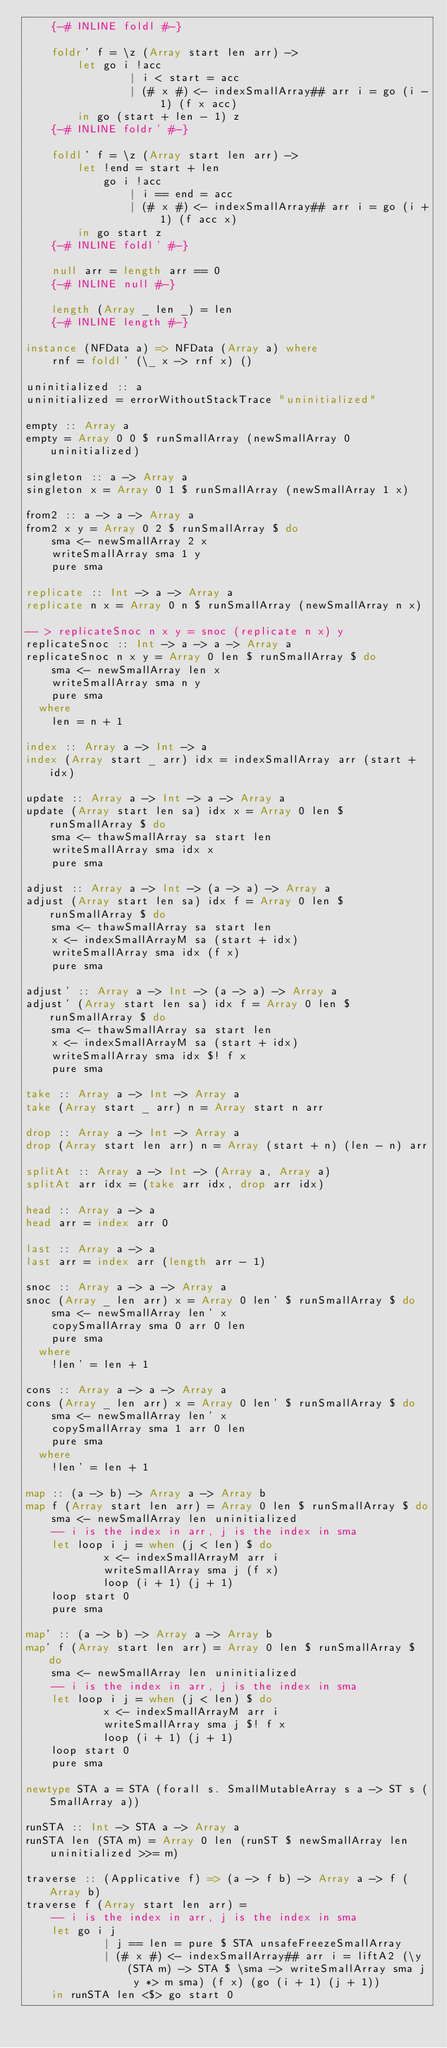<code> <loc_0><loc_0><loc_500><loc_500><_Haskell_>    {-# INLINE foldl #-}

    foldr' f = \z (Array start len arr) ->
        let go i !acc
                | i < start = acc
                | (# x #) <- indexSmallArray## arr i = go (i - 1) (f x acc)
        in go (start + len - 1) z
    {-# INLINE foldr' #-}

    foldl' f = \z (Array start len arr) ->
        let !end = start + len
            go i !acc
                | i == end = acc
                | (# x #) <- indexSmallArray## arr i = go (i + 1) (f acc x)
        in go start z
    {-# INLINE foldl' #-}

    null arr = length arr == 0
    {-# INLINE null #-}

    length (Array _ len _) = len
    {-# INLINE length #-}

instance (NFData a) => NFData (Array a) where
    rnf = foldl' (\_ x -> rnf x) ()

uninitialized :: a
uninitialized = errorWithoutStackTrace "uninitialized"

empty :: Array a
empty = Array 0 0 $ runSmallArray (newSmallArray 0 uninitialized)

singleton :: a -> Array a
singleton x = Array 0 1 $ runSmallArray (newSmallArray 1 x)

from2 :: a -> a -> Array a
from2 x y = Array 0 2 $ runSmallArray $ do
    sma <- newSmallArray 2 x
    writeSmallArray sma 1 y
    pure sma

replicate :: Int -> a -> Array a
replicate n x = Array 0 n $ runSmallArray (newSmallArray n x)

-- > replicateSnoc n x y = snoc (replicate n x) y
replicateSnoc :: Int -> a -> a -> Array a
replicateSnoc n x y = Array 0 len $ runSmallArray $ do
    sma <- newSmallArray len x
    writeSmallArray sma n y
    pure sma
  where
    len = n + 1

index :: Array a -> Int -> a
index (Array start _ arr) idx = indexSmallArray arr (start + idx)

update :: Array a -> Int -> a -> Array a
update (Array start len sa) idx x = Array 0 len $ runSmallArray $ do
    sma <- thawSmallArray sa start len
    writeSmallArray sma idx x
    pure sma

adjust :: Array a -> Int -> (a -> a) -> Array a
adjust (Array start len sa) idx f = Array 0 len $ runSmallArray $ do
    sma <- thawSmallArray sa start len
    x <- indexSmallArrayM sa (start + idx)
    writeSmallArray sma idx (f x)
    pure sma

adjust' :: Array a -> Int -> (a -> a) -> Array a
adjust' (Array start len sa) idx f = Array 0 len $ runSmallArray $ do
    sma <- thawSmallArray sa start len
    x <- indexSmallArrayM sa (start + idx)
    writeSmallArray sma idx $! f x
    pure sma

take :: Array a -> Int -> Array a
take (Array start _ arr) n = Array start n arr

drop :: Array a -> Int -> Array a
drop (Array start len arr) n = Array (start + n) (len - n) arr

splitAt :: Array a -> Int -> (Array a, Array a)
splitAt arr idx = (take arr idx, drop arr idx)

head :: Array a -> a
head arr = index arr 0

last :: Array a -> a
last arr = index arr (length arr - 1)

snoc :: Array a -> a -> Array a
snoc (Array _ len arr) x = Array 0 len' $ runSmallArray $ do
    sma <- newSmallArray len' x
    copySmallArray sma 0 arr 0 len
    pure sma
  where
    !len' = len + 1

cons :: Array a -> a -> Array a
cons (Array _ len arr) x = Array 0 len' $ runSmallArray $ do
    sma <- newSmallArray len' x
    copySmallArray sma 1 arr 0 len
    pure sma
  where
    !len' = len + 1

map :: (a -> b) -> Array a -> Array b
map f (Array start len arr) = Array 0 len $ runSmallArray $ do
    sma <- newSmallArray len uninitialized
    -- i is the index in arr, j is the index in sma
    let loop i j = when (j < len) $ do
            x <- indexSmallArrayM arr i
            writeSmallArray sma j (f x)
            loop (i + 1) (j + 1)
    loop start 0
    pure sma

map' :: (a -> b) -> Array a -> Array b
map' f (Array start len arr) = Array 0 len $ runSmallArray $ do
    sma <- newSmallArray len uninitialized
    -- i is the index in arr, j is the index in sma
    let loop i j = when (j < len) $ do
            x <- indexSmallArrayM arr i
            writeSmallArray sma j $! f x
            loop (i + 1) (j + 1)
    loop start 0
    pure sma

newtype STA a = STA (forall s. SmallMutableArray s a -> ST s (SmallArray a))

runSTA :: Int -> STA a -> Array a
runSTA len (STA m) = Array 0 len (runST $ newSmallArray len uninitialized >>= m)

traverse :: (Applicative f) => (a -> f b) -> Array a -> f (Array b)
traverse f (Array start len arr) =
    -- i is the index in arr, j is the index in sma
    let go i j
            | j == len = pure $ STA unsafeFreezeSmallArray
            | (# x #) <- indexSmallArray## arr i = liftA2 (\y (STA m) -> STA $ \sma -> writeSmallArray sma j y *> m sma) (f x) (go (i + 1) (j + 1))
    in runSTA len <$> go start 0
</code> 